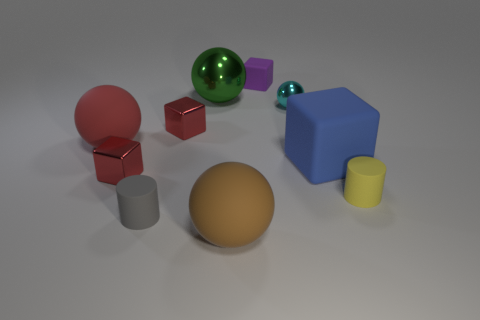There is another ball that is the same material as the green sphere; what color is it?
Keep it short and to the point. Cyan. Is there anything else that is the same size as the gray thing?
Offer a very short reply. Yes. How many big objects are either rubber cylinders or shiny objects?
Give a very brief answer. 1. Is the number of rubber cylinders less than the number of large yellow balls?
Offer a terse response. No. There is another large metallic object that is the same shape as the large brown object; what is its color?
Provide a short and direct response. Green. Is there any other thing that is the same shape as the green metal object?
Provide a succinct answer. Yes. Is the number of yellow cubes greater than the number of purple blocks?
Your answer should be compact. No. What number of other objects are there of the same material as the small purple block?
Your response must be concise. 5. There is a red metal object in front of the big matte thing right of the rubber cube left of the cyan metallic thing; what shape is it?
Make the answer very short. Cube. Is the number of tiny yellow cylinders to the left of the yellow matte object less than the number of tiny yellow rubber cylinders that are behind the small matte cube?
Keep it short and to the point. No. 